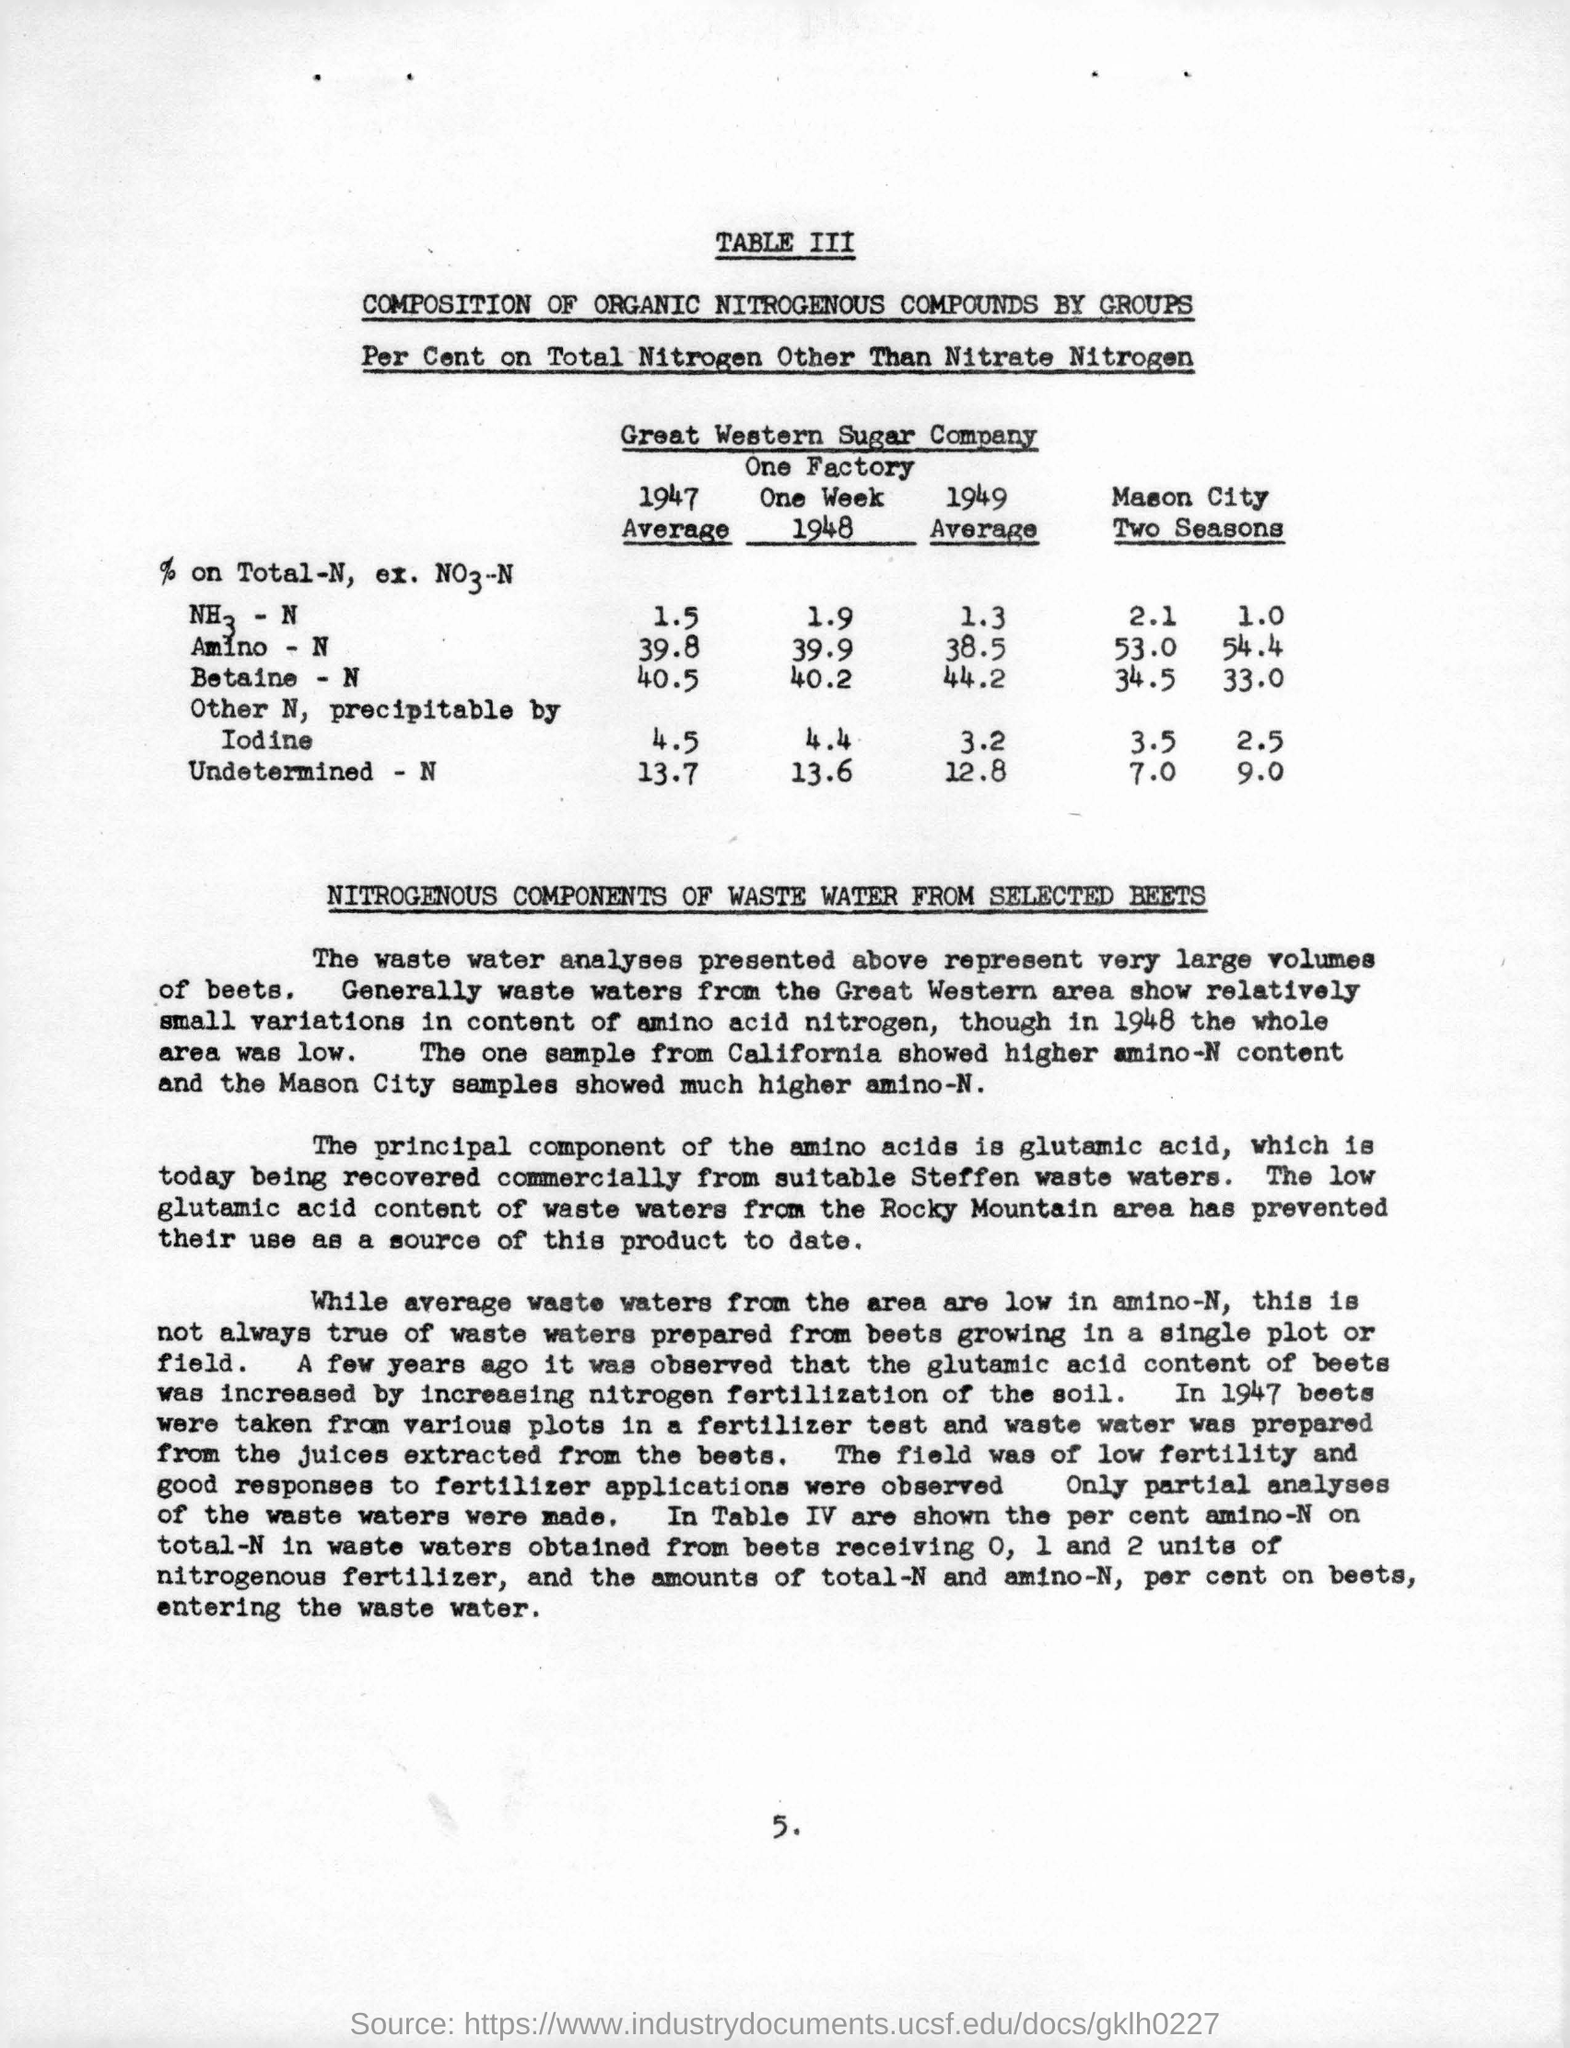Draw attention to some important aspects in this diagram. In 1947, the average percentage of total N in amino-N was 39.8%. The principal component of amino acids is glutamic acid. The value of iodine in Mason City during the second season is 2.5. The name of the company is the Great Western Sugar Company. The average value of betaine in 1949 was 44.2. 